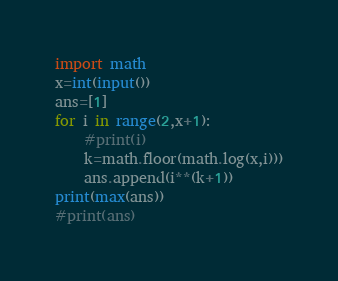<code> <loc_0><loc_0><loc_500><loc_500><_Python_>import math
x=int(input())
ans=[1]
for i in range(2,x+1):
    #print(i)
    k=math.floor(math.log(x,i)))
    ans.append(i**(k+1))
print(max(ans))
#print(ans)
</code> 